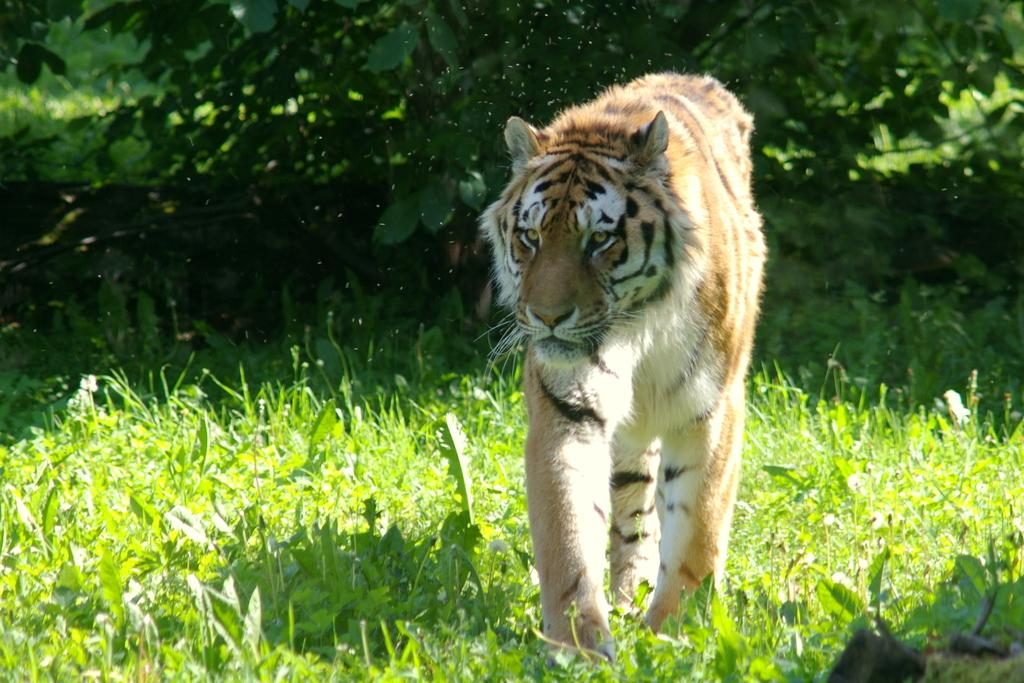What animal is the main subject of the image? There is a tiger in the image. What is the tiger standing on? The tiger is standing on grass. What can be seen in the background of the image? There are plants in the background of the image. What type of lunch is the tiger eating in the image? There is no lunch present in the image; the tiger is standing on grass with plants in the background. 